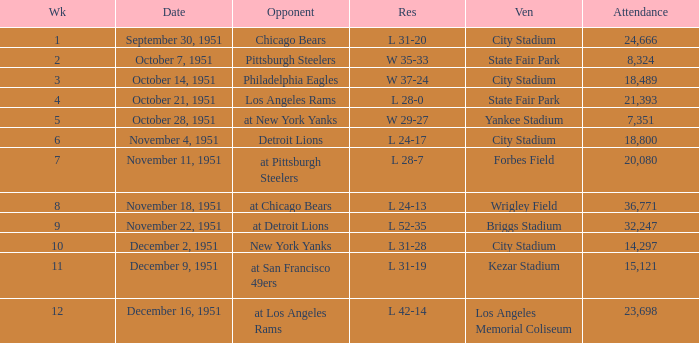Which venue hosted the Los Angeles Rams as an opponent? State Fair Park. 